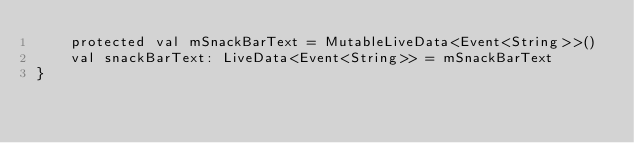Convert code to text. <code><loc_0><loc_0><loc_500><loc_500><_Kotlin_>    protected val mSnackBarText = MutableLiveData<Event<String>>()
    val snackBarText: LiveData<Event<String>> = mSnackBarText
}</code> 